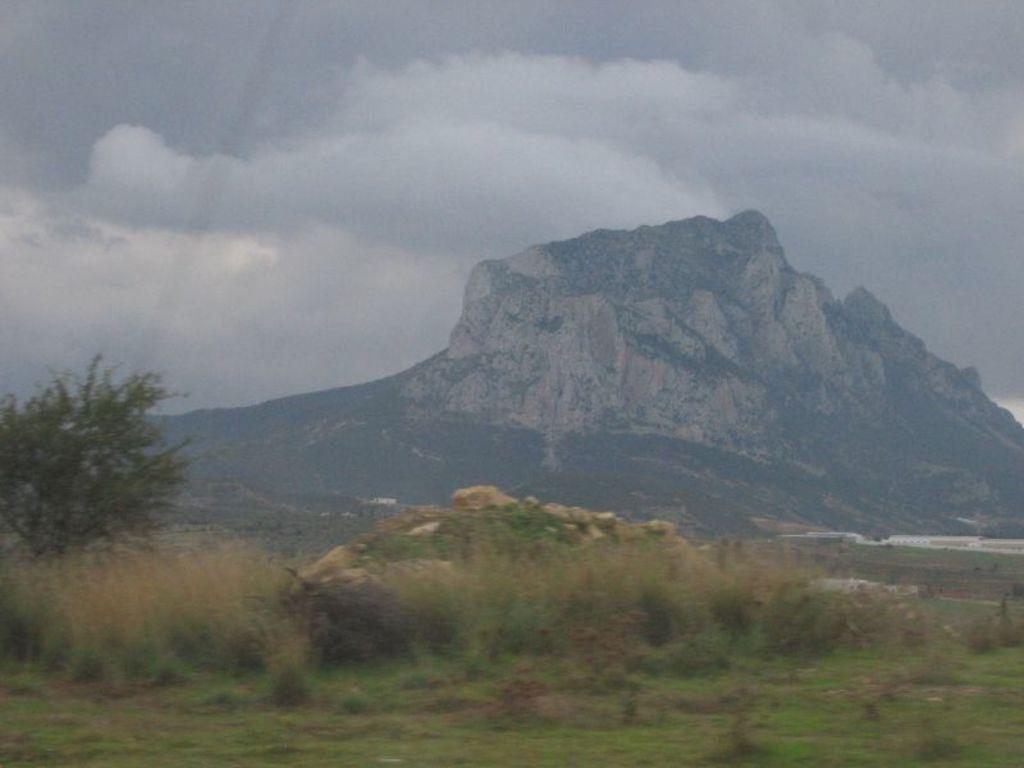Can you describe this image briefly? At the bottom of the image on the ground there is grass and also there are small plants. And also there are rocks and trees. In the background there is a hill. At the top of the image there is sky with clouds. 